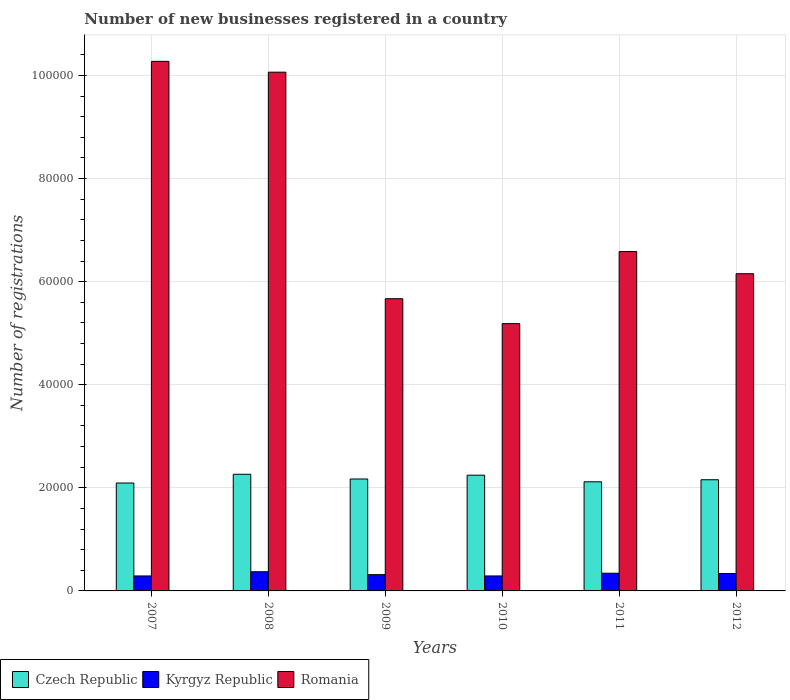How many groups of bars are there?
Offer a very short reply. 6. Are the number of bars on each tick of the X-axis equal?
Offer a terse response. Yes. How many bars are there on the 6th tick from the left?
Ensure brevity in your answer.  3. What is the label of the 6th group of bars from the left?
Your answer should be compact. 2012. In how many cases, is the number of bars for a given year not equal to the number of legend labels?
Ensure brevity in your answer.  0. What is the number of new businesses registered in Czech Republic in 2009?
Offer a very short reply. 2.17e+04. Across all years, what is the maximum number of new businesses registered in Romania?
Provide a short and direct response. 1.03e+05. Across all years, what is the minimum number of new businesses registered in Czech Republic?
Make the answer very short. 2.09e+04. In which year was the number of new businesses registered in Kyrgyz Republic maximum?
Provide a short and direct response. 2008. What is the total number of new businesses registered in Kyrgyz Republic in the graph?
Your answer should be compact. 1.95e+04. What is the difference between the number of new businesses registered in Kyrgyz Republic in 2009 and that in 2010?
Your answer should be compact. 256. What is the difference between the number of new businesses registered in Kyrgyz Republic in 2008 and the number of new businesses registered in Romania in 2010?
Your response must be concise. -4.81e+04. What is the average number of new businesses registered in Romania per year?
Your response must be concise. 7.32e+04. In the year 2007, what is the difference between the number of new businesses registered in Czech Republic and number of new businesses registered in Kyrgyz Republic?
Keep it short and to the point. 1.80e+04. In how many years, is the number of new businesses registered in Czech Republic greater than 96000?
Provide a succinct answer. 0. What is the ratio of the number of new businesses registered in Kyrgyz Republic in 2008 to that in 2011?
Make the answer very short. 1.08. Is the number of new businesses registered in Czech Republic in 2009 less than that in 2011?
Provide a succinct answer. No. What is the difference between the highest and the second highest number of new businesses registered in Czech Republic?
Your answer should be very brief. 177. What is the difference between the highest and the lowest number of new businesses registered in Romania?
Provide a short and direct response. 5.09e+04. What does the 1st bar from the left in 2007 represents?
Keep it short and to the point. Czech Republic. What does the 1st bar from the right in 2008 represents?
Provide a short and direct response. Romania. Are all the bars in the graph horizontal?
Keep it short and to the point. No. How many years are there in the graph?
Make the answer very short. 6. What is the difference between two consecutive major ticks on the Y-axis?
Ensure brevity in your answer.  2.00e+04. Does the graph contain any zero values?
Make the answer very short. No. How are the legend labels stacked?
Offer a very short reply. Horizontal. What is the title of the graph?
Your response must be concise. Number of new businesses registered in a country. Does "European Union" appear as one of the legend labels in the graph?
Provide a succinct answer. No. What is the label or title of the Y-axis?
Your response must be concise. Number of registrations. What is the Number of registrations of Czech Republic in 2007?
Provide a succinct answer. 2.09e+04. What is the Number of registrations in Kyrgyz Republic in 2007?
Provide a short and direct response. 2906. What is the Number of registrations in Romania in 2007?
Make the answer very short. 1.03e+05. What is the Number of registrations of Czech Republic in 2008?
Offer a terse response. 2.26e+04. What is the Number of registrations in Kyrgyz Republic in 2008?
Make the answer very short. 3721. What is the Number of registrations of Romania in 2008?
Your answer should be very brief. 1.01e+05. What is the Number of registrations in Czech Republic in 2009?
Provide a succinct answer. 2.17e+04. What is the Number of registrations in Kyrgyz Republic in 2009?
Offer a terse response. 3161. What is the Number of registrations of Romania in 2009?
Your response must be concise. 5.67e+04. What is the Number of registrations in Czech Republic in 2010?
Make the answer very short. 2.25e+04. What is the Number of registrations in Kyrgyz Republic in 2010?
Provide a short and direct response. 2905. What is the Number of registrations of Romania in 2010?
Ensure brevity in your answer.  5.19e+04. What is the Number of registrations in Czech Republic in 2011?
Your answer should be very brief. 2.12e+04. What is the Number of registrations in Kyrgyz Republic in 2011?
Your answer should be very brief. 3433. What is the Number of registrations in Romania in 2011?
Give a very brief answer. 6.58e+04. What is the Number of registrations in Czech Republic in 2012?
Provide a succinct answer. 2.16e+04. What is the Number of registrations of Kyrgyz Republic in 2012?
Provide a succinct answer. 3379. What is the Number of registrations of Romania in 2012?
Offer a terse response. 6.15e+04. Across all years, what is the maximum Number of registrations of Czech Republic?
Offer a very short reply. 2.26e+04. Across all years, what is the maximum Number of registrations in Kyrgyz Republic?
Offer a very short reply. 3721. Across all years, what is the maximum Number of registrations of Romania?
Your answer should be very brief. 1.03e+05. Across all years, what is the minimum Number of registrations of Czech Republic?
Provide a succinct answer. 2.09e+04. Across all years, what is the minimum Number of registrations of Kyrgyz Republic?
Your response must be concise. 2905. Across all years, what is the minimum Number of registrations in Romania?
Keep it short and to the point. 5.19e+04. What is the total Number of registrations of Czech Republic in the graph?
Provide a succinct answer. 1.30e+05. What is the total Number of registrations of Kyrgyz Republic in the graph?
Provide a short and direct response. 1.95e+04. What is the total Number of registrations in Romania in the graph?
Offer a very short reply. 4.39e+05. What is the difference between the Number of registrations of Czech Republic in 2007 and that in 2008?
Keep it short and to the point. -1695. What is the difference between the Number of registrations of Kyrgyz Republic in 2007 and that in 2008?
Keep it short and to the point. -815. What is the difference between the Number of registrations in Romania in 2007 and that in 2008?
Your response must be concise. 2099. What is the difference between the Number of registrations in Czech Republic in 2007 and that in 2009?
Give a very brief answer. -779. What is the difference between the Number of registrations of Kyrgyz Republic in 2007 and that in 2009?
Your answer should be very brief. -255. What is the difference between the Number of registrations in Romania in 2007 and that in 2009?
Keep it short and to the point. 4.61e+04. What is the difference between the Number of registrations in Czech Republic in 2007 and that in 2010?
Your response must be concise. -1518. What is the difference between the Number of registrations of Kyrgyz Republic in 2007 and that in 2010?
Ensure brevity in your answer.  1. What is the difference between the Number of registrations of Romania in 2007 and that in 2010?
Provide a short and direct response. 5.09e+04. What is the difference between the Number of registrations in Czech Republic in 2007 and that in 2011?
Offer a terse response. -235. What is the difference between the Number of registrations of Kyrgyz Republic in 2007 and that in 2011?
Keep it short and to the point. -527. What is the difference between the Number of registrations in Romania in 2007 and that in 2011?
Make the answer very short. 3.69e+04. What is the difference between the Number of registrations in Czech Republic in 2007 and that in 2012?
Give a very brief answer. -633. What is the difference between the Number of registrations of Kyrgyz Republic in 2007 and that in 2012?
Provide a short and direct response. -473. What is the difference between the Number of registrations in Romania in 2007 and that in 2012?
Your response must be concise. 4.12e+04. What is the difference between the Number of registrations in Czech Republic in 2008 and that in 2009?
Make the answer very short. 916. What is the difference between the Number of registrations in Kyrgyz Republic in 2008 and that in 2009?
Ensure brevity in your answer.  560. What is the difference between the Number of registrations of Romania in 2008 and that in 2009?
Your response must be concise. 4.40e+04. What is the difference between the Number of registrations in Czech Republic in 2008 and that in 2010?
Provide a succinct answer. 177. What is the difference between the Number of registrations in Kyrgyz Republic in 2008 and that in 2010?
Your response must be concise. 816. What is the difference between the Number of registrations of Romania in 2008 and that in 2010?
Give a very brief answer. 4.88e+04. What is the difference between the Number of registrations in Czech Republic in 2008 and that in 2011?
Your answer should be compact. 1460. What is the difference between the Number of registrations in Kyrgyz Republic in 2008 and that in 2011?
Your answer should be very brief. 288. What is the difference between the Number of registrations in Romania in 2008 and that in 2011?
Provide a short and direct response. 3.48e+04. What is the difference between the Number of registrations in Czech Republic in 2008 and that in 2012?
Your answer should be compact. 1062. What is the difference between the Number of registrations in Kyrgyz Republic in 2008 and that in 2012?
Your answer should be compact. 342. What is the difference between the Number of registrations in Romania in 2008 and that in 2012?
Your answer should be very brief. 3.91e+04. What is the difference between the Number of registrations of Czech Republic in 2009 and that in 2010?
Provide a succinct answer. -739. What is the difference between the Number of registrations in Kyrgyz Republic in 2009 and that in 2010?
Give a very brief answer. 256. What is the difference between the Number of registrations of Romania in 2009 and that in 2010?
Keep it short and to the point. 4831. What is the difference between the Number of registrations of Czech Republic in 2009 and that in 2011?
Ensure brevity in your answer.  544. What is the difference between the Number of registrations in Kyrgyz Republic in 2009 and that in 2011?
Give a very brief answer. -272. What is the difference between the Number of registrations of Romania in 2009 and that in 2011?
Ensure brevity in your answer.  -9152. What is the difference between the Number of registrations of Czech Republic in 2009 and that in 2012?
Offer a very short reply. 146. What is the difference between the Number of registrations in Kyrgyz Republic in 2009 and that in 2012?
Make the answer very short. -218. What is the difference between the Number of registrations of Romania in 2009 and that in 2012?
Give a very brief answer. -4852. What is the difference between the Number of registrations of Czech Republic in 2010 and that in 2011?
Offer a terse response. 1283. What is the difference between the Number of registrations in Kyrgyz Republic in 2010 and that in 2011?
Provide a succinct answer. -528. What is the difference between the Number of registrations in Romania in 2010 and that in 2011?
Keep it short and to the point. -1.40e+04. What is the difference between the Number of registrations in Czech Republic in 2010 and that in 2012?
Your answer should be compact. 885. What is the difference between the Number of registrations of Kyrgyz Republic in 2010 and that in 2012?
Offer a terse response. -474. What is the difference between the Number of registrations of Romania in 2010 and that in 2012?
Ensure brevity in your answer.  -9683. What is the difference between the Number of registrations in Czech Republic in 2011 and that in 2012?
Make the answer very short. -398. What is the difference between the Number of registrations of Kyrgyz Republic in 2011 and that in 2012?
Offer a very short reply. 54. What is the difference between the Number of registrations of Romania in 2011 and that in 2012?
Your answer should be very brief. 4300. What is the difference between the Number of registrations of Czech Republic in 2007 and the Number of registrations of Kyrgyz Republic in 2008?
Offer a terse response. 1.72e+04. What is the difference between the Number of registrations of Czech Republic in 2007 and the Number of registrations of Romania in 2008?
Offer a very short reply. -7.97e+04. What is the difference between the Number of registrations in Kyrgyz Republic in 2007 and the Number of registrations in Romania in 2008?
Your answer should be very brief. -9.77e+04. What is the difference between the Number of registrations of Czech Republic in 2007 and the Number of registrations of Kyrgyz Republic in 2009?
Provide a short and direct response. 1.78e+04. What is the difference between the Number of registrations of Czech Republic in 2007 and the Number of registrations of Romania in 2009?
Ensure brevity in your answer.  -3.58e+04. What is the difference between the Number of registrations in Kyrgyz Republic in 2007 and the Number of registrations in Romania in 2009?
Give a very brief answer. -5.38e+04. What is the difference between the Number of registrations of Czech Republic in 2007 and the Number of registrations of Kyrgyz Republic in 2010?
Your answer should be very brief. 1.80e+04. What is the difference between the Number of registrations of Czech Republic in 2007 and the Number of registrations of Romania in 2010?
Keep it short and to the point. -3.09e+04. What is the difference between the Number of registrations in Kyrgyz Republic in 2007 and the Number of registrations in Romania in 2010?
Offer a very short reply. -4.90e+04. What is the difference between the Number of registrations in Czech Republic in 2007 and the Number of registrations in Kyrgyz Republic in 2011?
Your answer should be compact. 1.75e+04. What is the difference between the Number of registrations in Czech Republic in 2007 and the Number of registrations in Romania in 2011?
Offer a very short reply. -4.49e+04. What is the difference between the Number of registrations in Kyrgyz Republic in 2007 and the Number of registrations in Romania in 2011?
Keep it short and to the point. -6.29e+04. What is the difference between the Number of registrations of Czech Republic in 2007 and the Number of registrations of Kyrgyz Republic in 2012?
Give a very brief answer. 1.76e+04. What is the difference between the Number of registrations of Czech Republic in 2007 and the Number of registrations of Romania in 2012?
Your response must be concise. -4.06e+04. What is the difference between the Number of registrations in Kyrgyz Republic in 2007 and the Number of registrations in Romania in 2012?
Ensure brevity in your answer.  -5.86e+04. What is the difference between the Number of registrations of Czech Republic in 2008 and the Number of registrations of Kyrgyz Republic in 2009?
Ensure brevity in your answer.  1.95e+04. What is the difference between the Number of registrations of Czech Republic in 2008 and the Number of registrations of Romania in 2009?
Your response must be concise. -3.41e+04. What is the difference between the Number of registrations of Kyrgyz Republic in 2008 and the Number of registrations of Romania in 2009?
Give a very brief answer. -5.30e+04. What is the difference between the Number of registrations of Czech Republic in 2008 and the Number of registrations of Kyrgyz Republic in 2010?
Ensure brevity in your answer.  1.97e+04. What is the difference between the Number of registrations of Czech Republic in 2008 and the Number of registrations of Romania in 2010?
Provide a succinct answer. -2.92e+04. What is the difference between the Number of registrations of Kyrgyz Republic in 2008 and the Number of registrations of Romania in 2010?
Offer a very short reply. -4.81e+04. What is the difference between the Number of registrations in Czech Republic in 2008 and the Number of registrations in Kyrgyz Republic in 2011?
Give a very brief answer. 1.92e+04. What is the difference between the Number of registrations of Czech Republic in 2008 and the Number of registrations of Romania in 2011?
Your answer should be very brief. -4.32e+04. What is the difference between the Number of registrations in Kyrgyz Republic in 2008 and the Number of registrations in Romania in 2011?
Make the answer very short. -6.21e+04. What is the difference between the Number of registrations in Czech Republic in 2008 and the Number of registrations in Kyrgyz Republic in 2012?
Offer a very short reply. 1.93e+04. What is the difference between the Number of registrations of Czech Republic in 2008 and the Number of registrations of Romania in 2012?
Your answer should be compact. -3.89e+04. What is the difference between the Number of registrations of Kyrgyz Republic in 2008 and the Number of registrations of Romania in 2012?
Offer a very short reply. -5.78e+04. What is the difference between the Number of registrations of Czech Republic in 2009 and the Number of registrations of Kyrgyz Republic in 2010?
Give a very brief answer. 1.88e+04. What is the difference between the Number of registrations in Czech Republic in 2009 and the Number of registrations in Romania in 2010?
Offer a terse response. -3.01e+04. What is the difference between the Number of registrations of Kyrgyz Republic in 2009 and the Number of registrations of Romania in 2010?
Ensure brevity in your answer.  -4.87e+04. What is the difference between the Number of registrations in Czech Republic in 2009 and the Number of registrations in Kyrgyz Republic in 2011?
Give a very brief answer. 1.83e+04. What is the difference between the Number of registrations of Czech Republic in 2009 and the Number of registrations of Romania in 2011?
Give a very brief answer. -4.41e+04. What is the difference between the Number of registrations of Kyrgyz Republic in 2009 and the Number of registrations of Romania in 2011?
Offer a very short reply. -6.27e+04. What is the difference between the Number of registrations in Czech Republic in 2009 and the Number of registrations in Kyrgyz Republic in 2012?
Keep it short and to the point. 1.83e+04. What is the difference between the Number of registrations of Czech Republic in 2009 and the Number of registrations of Romania in 2012?
Offer a terse response. -3.98e+04. What is the difference between the Number of registrations of Kyrgyz Republic in 2009 and the Number of registrations of Romania in 2012?
Give a very brief answer. -5.84e+04. What is the difference between the Number of registrations in Czech Republic in 2010 and the Number of registrations in Kyrgyz Republic in 2011?
Your answer should be very brief. 1.90e+04. What is the difference between the Number of registrations in Czech Republic in 2010 and the Number of registrations in Romania in 2011?
Offer a terse response. -4.34e+04. What is the difference between the Number of registrations in Kyrgyz Republic in 2010 and the Number of registrations in Romania in 2011?
Provide a short and direct response. -6.29e+04. What is the difference between the Number of registrations in Czech Republic in 2010 and the Number of registrations in Kyrgyz Republic in 2012?
Offer a very short reply. 1.91e+04. What is the difference between the Number of registrations in Czech Republic in 2010 and the Number of registrations in Romania in 2012?
Provide a succinct answer. -3.91e+04. What is the difference between the Number of registrations of Kyrgyz Republic in 2010 and the Number of registrations of Romania in 2012?
Make the answer very short. -5.86e+04. What is the difference between the Number of registrations of Czech Republic in 2011 and the Number of registrations of Kyrgyz Republic in 2012?
Your response must be concise. 1.78e+04. What is the difference between the Number of registrations of Czech Republic in 2011 and the Number of registrations of Romania in 2012?
Your answer should be very brief. -4.04e+04. What is the difference between the Number of registrations of Kyrgyz Republic in 2011 and the Number of registrations of Romania in 2012?
Provide a short and direct response. -5.81e+04. What is the average Number of registrations in Czech Republic per year?
Ensure brevity in your answer.  2.17e+04. What is the average Number of registrations of Kyrgyz Republic per year?
Your response must be concise. 3250.83. What is the average Number of registrations of Romania per year?
Your answer should be compact. 7.32e+04. In the year 2007, what is the difference between the Number of registrations of Czech Republic and Number of registrations of Kyrgyz Republic?
Make the answer very short. 1.80e+04. In the year 2007, what is the difference between the Number of registrations in Czech Republic and Number of registrations in Romania?
Offer a very short reply. -8.18e+04. In the year 2007, what is the difference between the Number of registrations of Kyrgyz Republic and Number of registrations of Romania?
Keep it short and to the point. -9.98e+04. In the year 2008, what is the difference between the Number of registrations of Czech Republic and Number of registrations of Kyrgyz Republic?
Your answer should be compact. 1.89e+04. In the year 2008, what is the difference between the Number of registrations of Czech Republic and Number of registrations of Romania?
Ensure brevity in your answer.  -7.80e+04. In the year 2008, what is the difference between the Number of registrations of Kyrgyz Republic and Number of registrations of Romania?
Make the answer very short. -9.69e+04. In the year 2009, what is the difference between the Number of registrations in Czech Republic and Number of registrations in Kyrgyz Republic?
Offer a terse response. 1.86e+04. In the year 2009, what is the difference between the Number of registrations of Czech Republic and Number of registrations of Romania?
Your response must be concise. -3.50e+04. In the year 2009, what is the difference between the Number of registrations of Kyrgyz Republic and Number of registrations of Romania?
Provide a short and direct response. -5.35e+04. In the year 2010, what is the difference between the Number of registrations in Czech Republic and Number of registrations in Kyrgyz Republic?
Your answer should be very brief. 1.96e+04. In the year 2010, what is the difference between the Number of registrations of Czech Republic and Number of registrations of Romania?
Give a very brief answer. -2.94e+04. In the year 2010, what is the difference between the Number of registrations in Kyrgyz Republic and Number of registrations in Romania?
Offer a very short reply. -4.90e+04. In the year 2011, what is the difference between the Number of registrations in Czech Republic and Number of registrations in Kyrgyz Republic?
Your answer should be compact. 1.77e+04. In the year 2011, what is the difference between the Number of registrations of Czech Republic and Number of registrations of Romania?
Your answer should be compact. -4.47e+04. In the year 2011, what is the difference between the Number of registrations of Kyrgyz Republic and Number of registrations of Romania?
Provide a short and direct response. -6.24e+04. In the year 2012, what is the difference between the Number of registrations of Czech Republic and Number of registrations of Kyrgyz Republic?
Your answer should be compact. 1.82e+04. In the year 2012, what is the difference between the Number of registrations of Czech Republic and Number of registrations of Romania?
Offer a very short reply. -4.00e+04. In the year 2012, what is the difference between the Number of registrations of Kyrgyz Republic and Number of registrations of Romania?
Give a very brief answer. -5.82e+04. What is the ratio of the Number of registrations in Czech Republic in 2007 to that in 2008?
Provide a short and direct response. 0.93. What is the ratio of the Number of registrations of Kyrgyz Republic in 2007 to that in 2008?
Ensure brevity in your answer.  0.78. What is the ratio of the Number of registrations in Romania in 2007 to that in 2008?
Offer a terse response. 1.02. What is the ratio of the Number of registrations of Czech Republic in 2007 to that in 2009?
Offer a very short reply. 0.96. What is the ratio of the Number of registrations in Kyrgyz Republic in 2007 to that in 2009?
Offer a terse response. 0.92. What is the ratio of the Number of registrations in Romania in 2007 to that in 2009?
Ensure brevity in your answer.  1.81. What is the ratio of the Number of registrations in Czech Republic in 2007 to that in 2010?
Your response must be concise. 0.93. What is the ratio of the Number of registrations of Kyrgyz Republic in 2007 to that in 2010?
Provide a succinct answer. 1. What is the ratio of the Number of registrations in Romania in 2007 to that in 2010?
Your answer should be compact. 1.98. What is the ratio of the Number of registrations in Czech Republic in 2007 to that in 2011?
Ensure brevity in your answer.  0.99. What is the ratio of the Number of registrations of Kyrgyz Republic in 2007 to that in 2011?
Ensure brevity in your answer.  0.85. What is the ratio of the Number of registrations of Romania in 2007 to that in 2011?
Ensure brevity in your answer.  1.56. What is the ratio of the Number of registrations of Czech Republic in 2007 to that in 2012?
Keep it short and to the point. 0.97. What is the ratio of the Number of registrations of Kyrgyz Republic in 2007 to that in 2012?
Your response must be concise. 0.86. What is the ratio of the Number of registrations of Romania in 2007 to that in 2012?
Ensure brevity in your answer.  1.67. What is the ratio of the Number of registrations in Czech Republic in 2008 to that in 2009?
Provide a short and direct response. 1.04. What is the ratio of the Number of registrations in Kyrgyz Republic in 2008 to that in 2009?
Make the answer very short. 1.18. What is the ratio of the Number of registrations of Romania in 2008 to that in 2009?
Offer a terse response. 1.78. What is the ratio of the Number of registrations of Czech Republic in 2008 to that in 2010?
Your answer should be very brief. 1.01. What is the ratio of the Number of registrations of Kyrgyz Republic in 2008 to that in 2010?
Your answer should be compact. 1.28. What is the ratio of the Number of registrations of Romania in 2008 to that in 2010?
Your response must be concise. 1.94. What is the ratio of the Number of registrations in Czech Republic in 2008 to that in 2011?
Provide a short and direct response. 1.07. What is the ratio of the Number of registrations of Kyrgyz Republic in 2008 to that in 2011?
Give a very brief answer. 1.08. What is the ratio of the Number of registrations of Romania in 2008 to that in 2011?
Offer a terse response. 1.53. What is the ratio of the Number of registrations in Czech Republic in 2008 to that in 2012?
Your answer should be very brief. 1.05. What is the ratio of the Number of registrations of Kyrgyz Republic in 2008 to that in 2012?
Ensure brevity in your answer.  1.1. What is the ratio of the Number of registrations of Romania in 2008 to that in 2012?
Keep it short and to the point. 1.64. What is the ratio of the Number of registrations of Czech Republic in 2009 to that in 2010?
Your response must be concise. 0.97. What is the ratio of the Number of registrations in Kyrgyz Republic in 2009 to that in 2010?
Your answer should be compact. 1.09. What is the ratio of the Number of registrations of Romania in 2009 to that in 2010?
Give a very brief answer. 1.09. What is the ratio of the Number of registrations in Czech Republic in 2009 to that in 2011?
Make the answer very short. 1.03. What is the ratio of the Number of registrations in Kyrgyz Republic in 2009 to that in 2011?
Your answer should be very brief. 0.92. What is the ratio of the Number of registrations in Romania in 2009 to that in 2011?
Your answer should be very brief. 0.86. What is the ratio of the Number of registrations in Czech Republic in 2009 to that in 2012?
Make the answer very short. 1.01. What is the ratio of the Number of registrations of Kyrgyz Republic in 2009 to that in 2012?
Provide a succinct answer. 0.94. What is the ratio of the Number of registrations of Romania in 2009 to that in 2012?
Make the answer very short. 0.92. What is the ratio of the Number of registrations in Czech Republic in 2010 to that in 2011?
Offer a very short reply. 1.06. What is the ratio of the Number of registrations in Kyrgyz Republic in 2010 to that in 2011?
Provide a short and direct response. 0.85. What is the ratio of the Number of registrations of Romania in 2010 to that in 2011?
Your response must be concise. 0.79. What is the ratio of the Number of registrations in Czech Republic in 2010 to that in 2012?
Make the answer very short. 1.04. What is the ratio of the Number of registrations of Kyrgyz Republic in 2010 to that in 2012?
Your answer should be very brief. 0.86. What is the ratio of the Number of registrations in Romania in 2010 to that in 2012?
Your answer should be very brief. 0.84. What is the ratio of the Number of registrations in Czech Republic in 2011 to that in 2012?
Provide a succinct answer. 0.98. What is the ratio of the Number of registrations in Romania in 2011 to that in 2012?
Keep it short and to the point. 1.07. What is the difference between the highest and the second highest Number of registrations of Czech Republic?
Your response must be concise. 177. What is the difference between the highest and the second highest Number of registrations in Kyrgyz Republic?
Provide a succinct answer. 288. What is the difference between the highest and the second highest Number of registrations in Romania?
Make the answer very short. 2099. What is the difference between the highest and the lowest Number of registrations in Czech Republic?
Make the answer very short. 1695. What is the difference between the highest and the lowest Number of registrations in Kyrgyz Republic?
Give a very brief answer. 816. What is the difference between the highest and the lowest Number of registrations of Romania?
Give a very brief answer. 5.09e+04. 